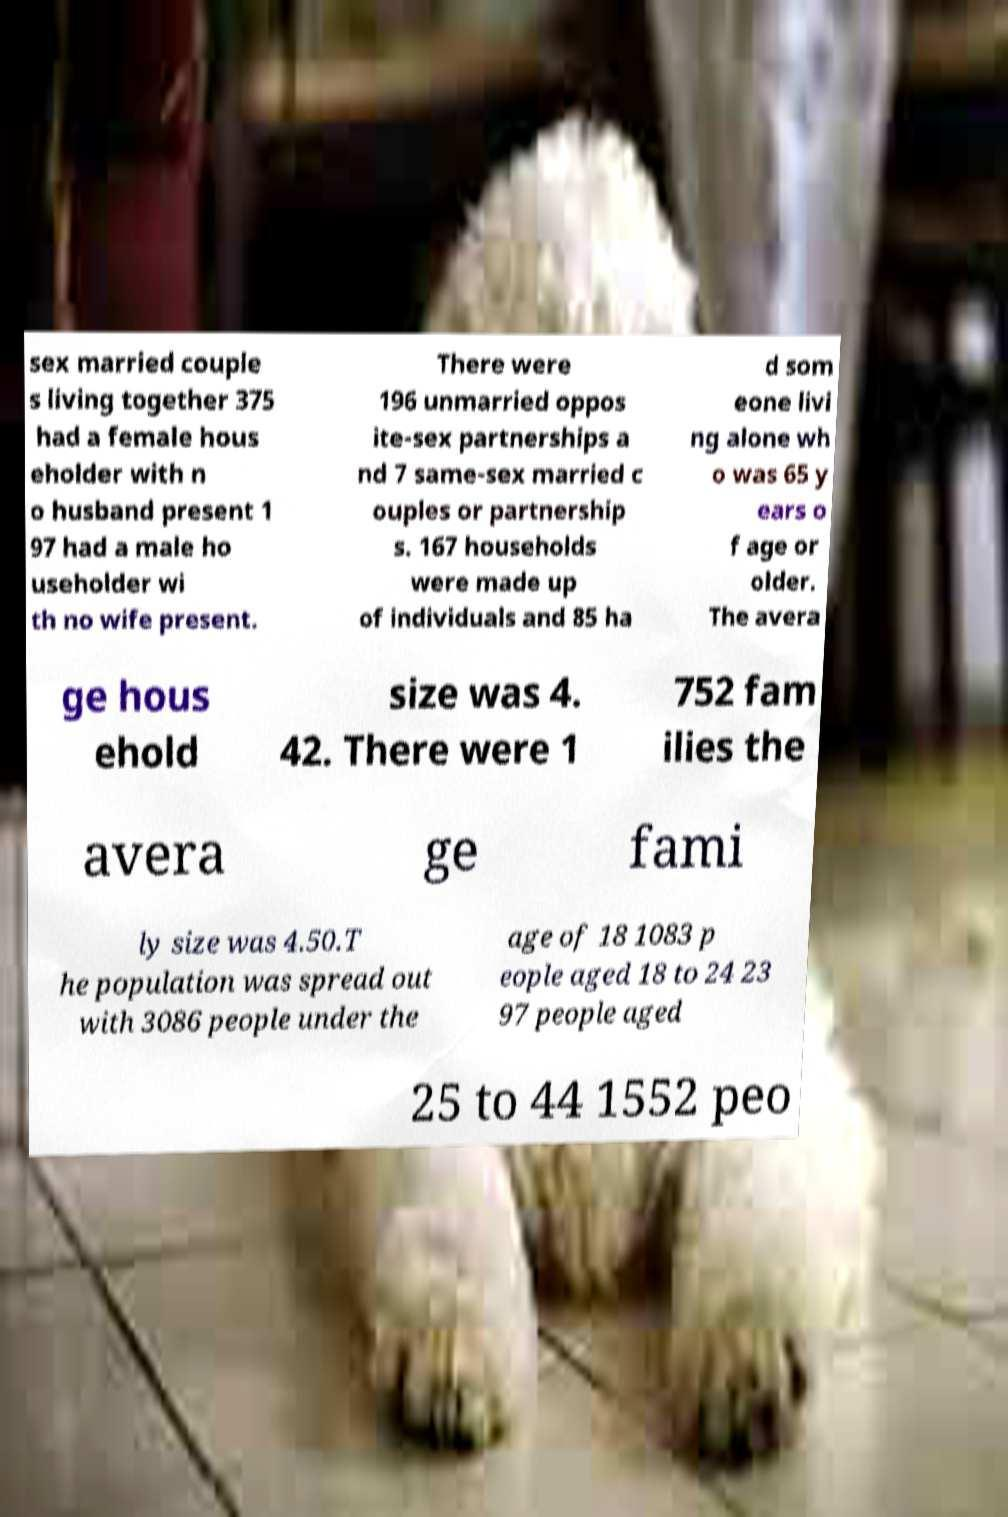Please read and relay the text visible in this image. What does it say? sex married couple s living together 375 had a female hous eholder with n o husband present 1 97 had a male ho useholder wi th no wife present. There were 196 unmarried oppos ite-sex partnerships a nd 7 same-sex married c ouples or partnership s. 167 households were made up of individuals and 85 ha d som eone livi ng alone wh o was 65 y ears o f age or older. The avera ge hous ehold size was 4. 42. There were 1 752 fam ilies the avera ge fami ly size was 4.50.T he population was spread out with 3086 people under the age of 18 1083 p eople aged 18 to 24 23 97 people aged 25 to 44 1552 peo 